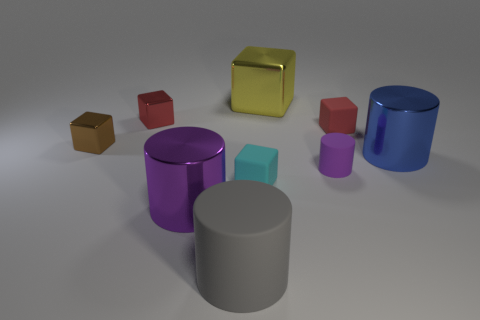Subtract 2 blocks. How many blocks are left? 3 Subtract all brown cylinders. Subtract all red balls. How many cylinders are left? 4 Add 1 small cyan matte things. How many objects exist? 10 Subtract all blocks. How many objects are left? 4 Add 5 small brown objects. How many small brown objects exist? 6 Subtract 0 brown spheres. How many objects are left? 9 Subtract all big gray things. Subtract all tiny red rubber things. How many objects are left? 7 Add 7 large purple shiny cylinders. How many large purple shiny cylinders are left? 8 